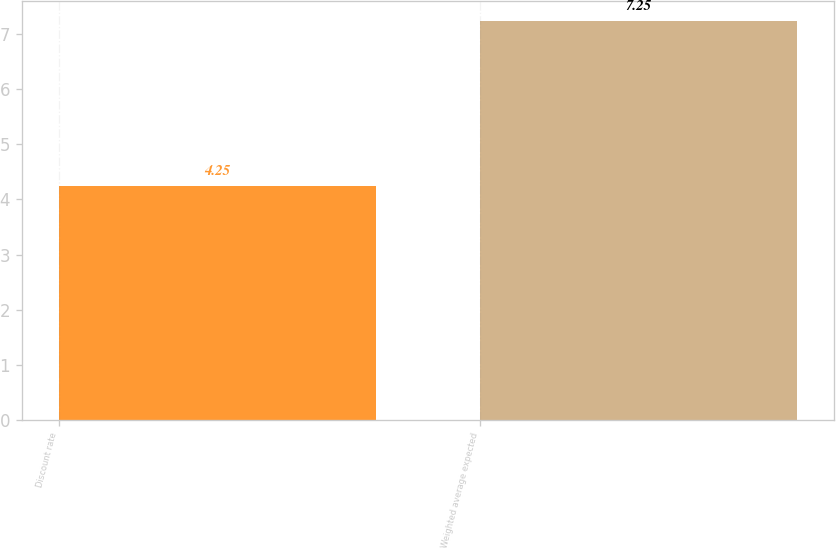Convert chart to OTSL. <chart><loc_0><loc_0><loc_500><loc_500><bar_chart><fcel>Discount rate<fcel>Weighted average expected<nl><fcel>4.25<fcel>7.25<nl></chart> 